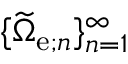Convert formula to latex. <formula><loc_0><loc_0><loc_500><loc_500>\{ \widetilde { \Omega } _ { e ; n } \} _ { n = 1 } ^ { \infty }</formula> 